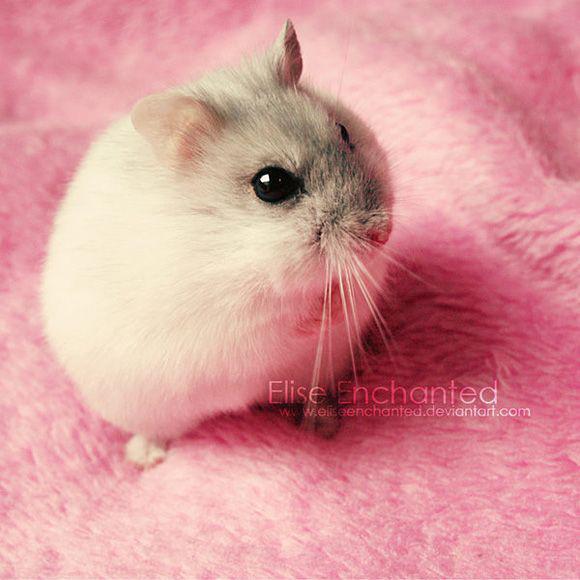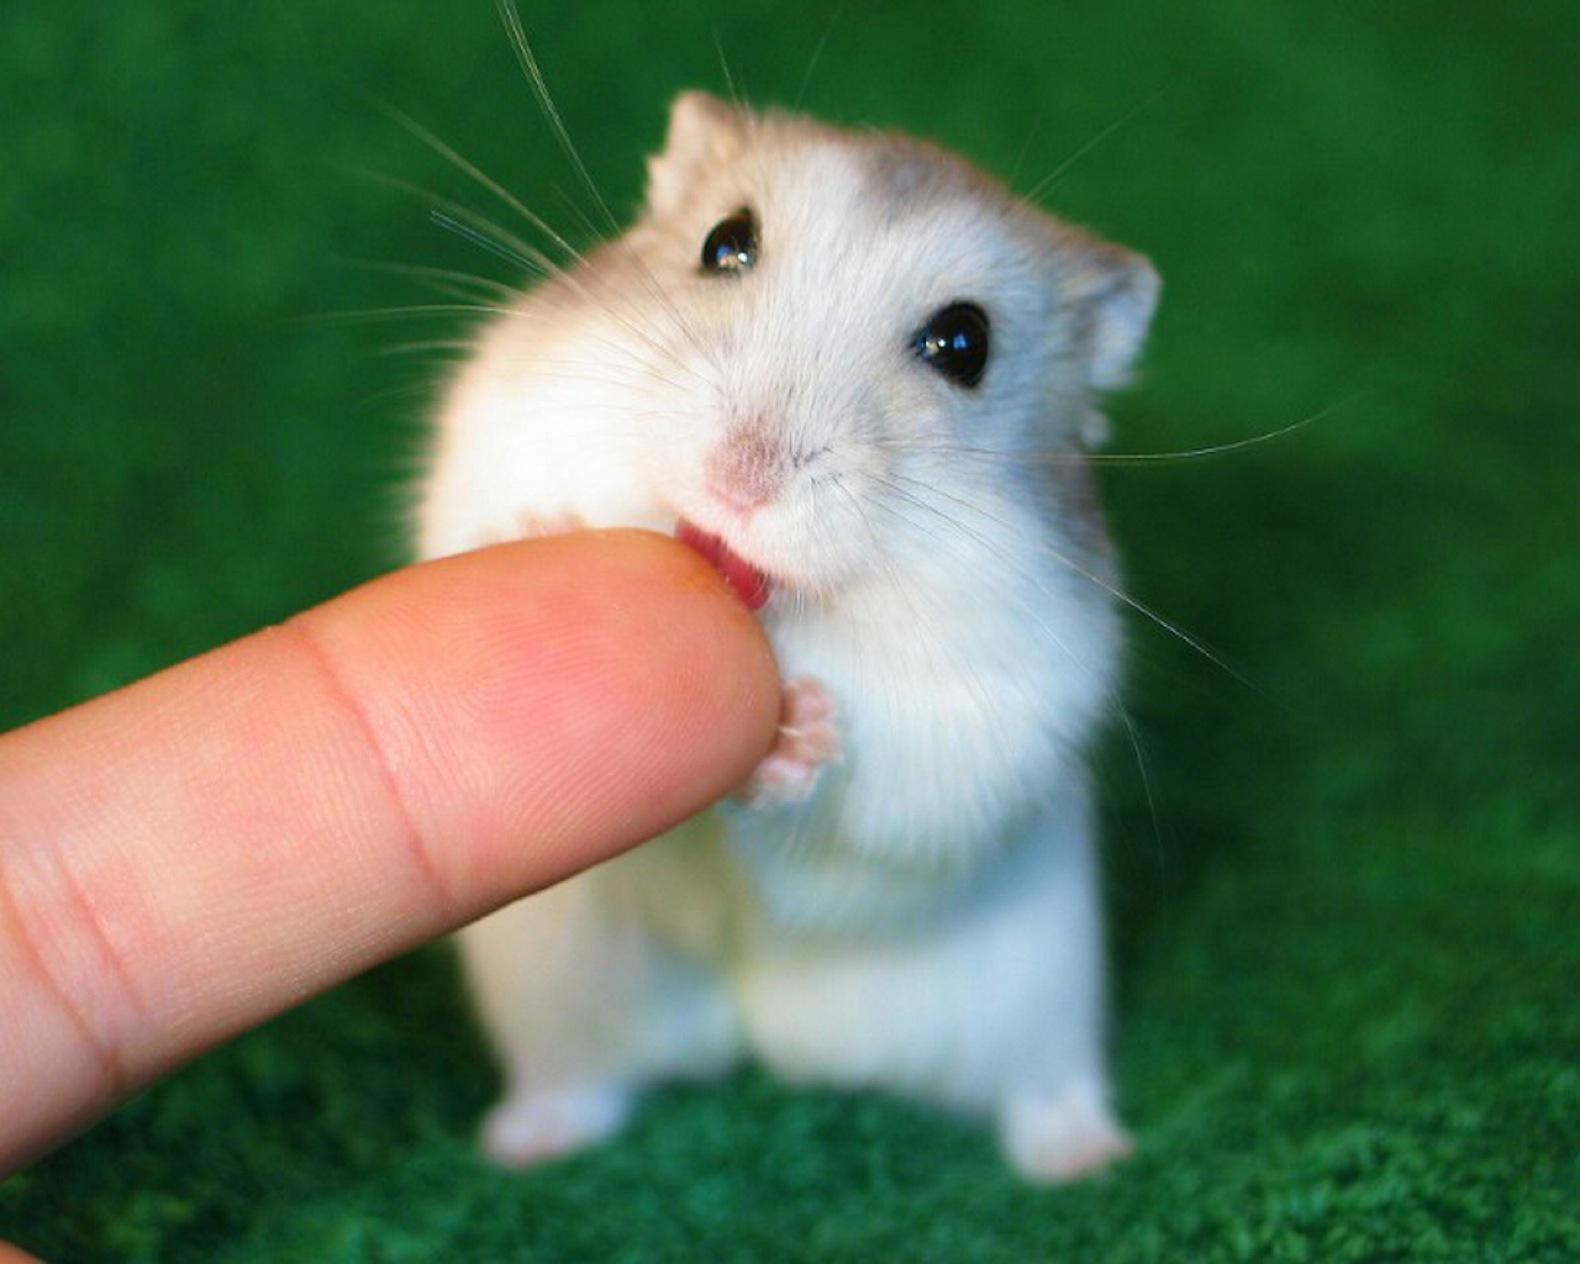The first image is the image on the left, the second image is the image on the right. Evaluate the accuracy of this statement regarding the images: "A hamster is holding a string.". Is it true? Answer yes or no. No. 